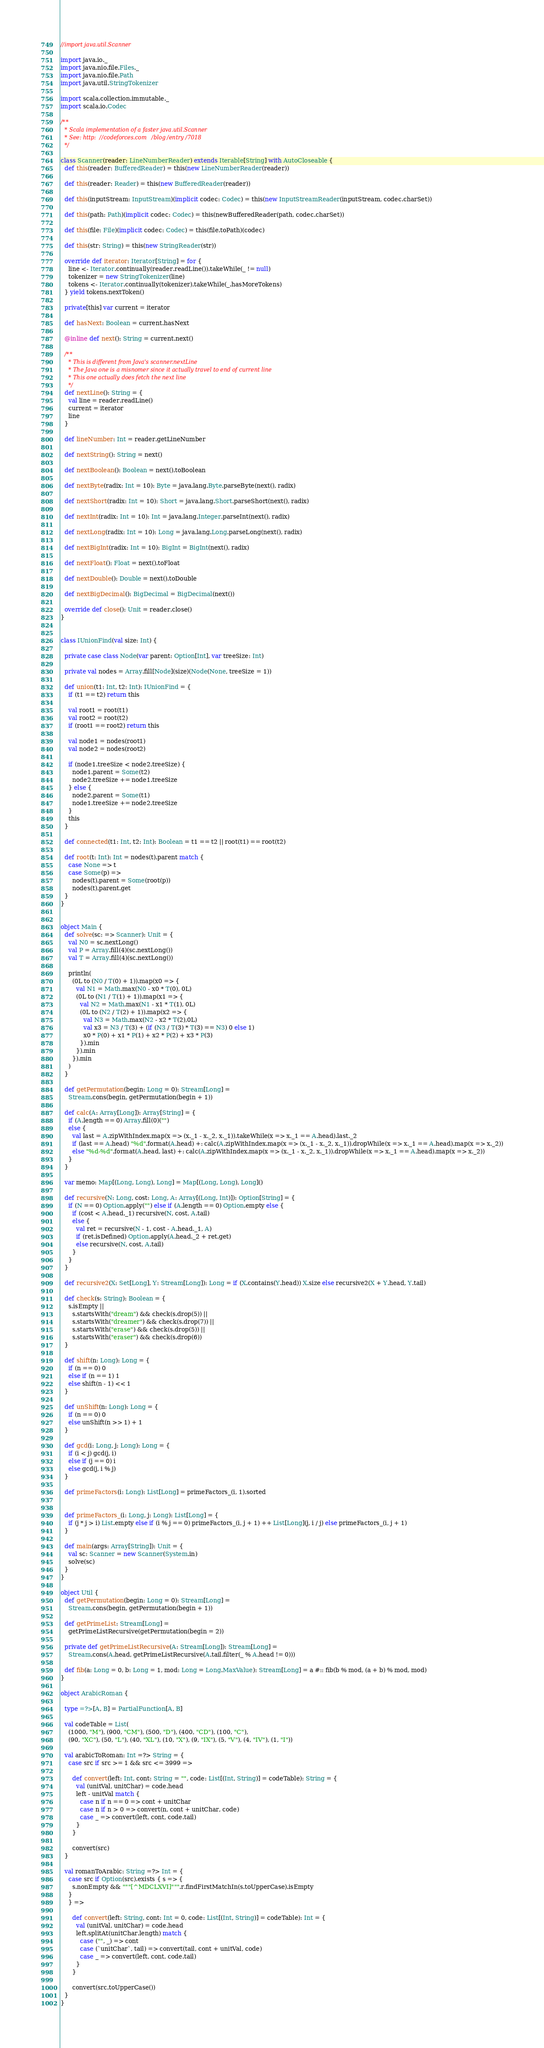<code> <loc_0><loc_0><loc_500><loc_500><_Scala_>//import java.util.Scanner

import java.io._
import java.nio.file.Files._
import java.nio.file.Path
import java.util.StringTokenizer

import scala.collection.immutable._
import scala.io.Codec

/**
  * Scala implementation of a faster java.util.Scanner
  * See: http://codeforces.com/blog/entry/7018
  */

class Scanner(reader: LineNumberReader) extends Iterable[String] with AutoCloseable {
  def this(reader: BufferedReader) = this(new LineNumberReader(reader))

  def this(reader: Reader) = this(new BufferedReader(reader))

  def this(inputStream: InputStream)(implicit codec: Codec) = this(new InputStreamReader(inputStream, codec.charSet))

  def this(path: Path)(implicit codec: Codec) = this(newBufferedReader(path, codec.charSet))

  def this(file: File)(implicit codec: Codec) = this(file.toPath)(codec)

  def this(str: String) = this(new StringReader(str))

  override def iterator: Iterator[String] = for {
    line <- Iterator.continually(reader.readLine()).takeWhile(_ != null)
    tokenizer = new StringTokenizer(line)
    tokens <- Iterator.continually(tokenizer).takeWhile(_.hasMoreTokens)
  } yield tokens.nextToken()

  private[this] var current = iterator

  def hasNext: Boolean = current.hasNext

  @inline def next(): String = current.next()

  /**
    * This is different from Java's scanner.nextLine
    * The Java one is a misnomer since it actually travel to end of current line
    * This one actually does fetch the next line
    */
  def nextLine(): String = {
    val line = reader.readLine()
    current = iterator
    line
  }

  def lineNumber: Int = reader.getLineNumber

  def nextString(): String = next()

  def nextBoolean(): Boolean = next().toBoolean

  def nextByte(radix: Int = 10): Byte = java.lang.Byte.parseByte(next(), radix)

  def nextShort(radix: Int = 10): Short = java.lang.Short.parseShort(next(), radix)

  def nextInt(radix: Int = 10): Int = java.lang.Integer.parseInt(next(), radix)

  def nextLong(radix: Int = 10): Long = java.lang.Long.parseLong(next(), radix)

  def nextBigInt(radix: Int = 10): BigInt = BigInt(next(), radix)

  def nextFloat(): Float = next().toFloat

  def nextDouble(): Double = next().toDouble

  def nextBigDecimal(): BigDecimal = BigDecimal(next())

  override def close(): Unit = reader.close()
}


class IUnionFind(val size: Int) {

  private case class Node(var parent: Option[Int], var treeSize: Int)

  private val nodes = Array.fill[Node](size)(Node(None, treeSize = 1))

  def union(t1: Int, t2: Int): IUnionFind = {
    if (t1 == t2) return this

    val root1 = root(t1)
    val root2 = root(t2)
    if (root1 == root2) return this

    val node1 = nodes(root1)
    val node2 = nodes(root2)

    if (node1.treeSize < node2.treeSize) {
      node1.parent = Some(t2)
      node2.treeSize += node1.treeSize
    } else {
      node2.parent = Some(t1)
      node1.treeSize += node2.treeSize
    }
    this
  }

  def connected(t1: Int, t2: Int): Boolean = t1 == t2 || root(t1) == root(t2)

  def root(t: Int): Int = nodes(t).parent match {
    case None => t
    case Some(p) =>
      nodes(t).parent = Some(root(p))
      nodes(t).parent.get
  }
}


object Main {
  def solve(sc: => Scanner): Unit = {
    val N0 = sc.nextLong()
    val P = Array.fill(4)(sc.nextLong())
    val T = Array.fill(4)(sc.nextLong())

    println(
      (0L to (N0 / T(0) + 1)).map(x0 => {
        val N1 = Math.max(N0 - x0 * T(0), 0L)
        (0L to (N1 / T(1) + 1)).map(x1 => {
          val N2 = Math.max(N1 - x1 * T(1), 0L)
          (0L to (N2 / T(2) + 1)).map(x2 => {
            val N3 = Math.max(N2 - x2 * T(2),0L)
            val x3 = N3 / T(3) + (if (N3 / T(3) * T(3) == N3) 0 else 1)
            x0 * P(0) + x1 * P(1) + x2 * P(2) + x3 * P(3)
          }).min
        }).min
      }).min
    )
  }

  def getPermutation(begin: Long = 0): Stream[Long] =
    Stream.cons(begin, getPermutation(begin + 1))

  def calc(A: Array[Long]): Array[String] = {
    if (A.length == 0) Array.fill(0)("")
    else {
      val last = A.zipWithIndex.map(x => (x._1 - x._2, x._1)).takeWhile(x => x._1 == A.head).last._2
      if (last == A.head) "%d".format(A.head) +: calc(A.zipWithIndex.map(x => (x._1 - x._2, x._1)).dropWhile(x => x._1 == A.head).map(x => x._2))
      else "%d-%d".format(A.head, last) +: calc(A.zipWithIndex.map(x => (x._1 - x._2, x._1)).dropWhile(x => x._1 == A.head).map(x => x._2))
    }
  }

  var memo: Map[(Long, Long), Long] = Map[(Long, Long), Long]()

  def recursive(N: Long, cost: Long, A: Array[(Long, Int)]): Option[String] = {
    if (N == 0) Option.apply("") else if (A.length == 0) Option.empty else {
      if (cost < A.head._1) recursive(N, cost, A.tail)
      else {
        val ret = recursive(N - 1, cost - A.head._1, A)
        if (ret.isDefined) Option.apply(A.head._2 + ret.get)
        else recursive(N, cost, A.tail)
      }
    }
  }

  def recursive2(X: Set[Long], Y: Stream[Long]): Long = if (X.contains(Y.head)) X.size else recursive2(X + Y.head, Y.tail)

  def check(s: String): Boolean = {
    s.isEmpty ||
      s.startsWith("dream") && check(s.drop(5)) ||
      s.startsWith("dreamer") && check(s.drop(7)) ||
      s.startsWith("erase") && check(s.drop(5)) ||
      s.startsWith("eraser") && check(s.drop(6))
  }

  def shift(n: Long): Long = {
    if (n == 0) 0
    else if (n == 1) 1
    else shift(n - 1) << 1
  }

  def unShift(n: Long): Long = {
    if (n == 0) 0
    else unShift(n >> 1) + 1
  }

  def gcd(i: Long, j: Long): Long = {
    if (i < j) gcd(j, i)
    else if (j == 0) i
    else gcd(j, i % j)
  }

  def primeFactors(i: Long): List[Long] = primeFactors_(i, 1).sorted


  def primeFactors_(i: Long, j: Long): List[Long] = {
    if (j * j > i) List.empty else if (i % j == 0) primeFactors_(i, j + 1) ++ List[Long](j, i / j) else primeFactors_(i, j + 1)
  }

  def main(args: Array[String]): Unit = {
    val sc: Scanner = new Scanner(System.in)
    solve(sc)
  }
}

object Util {
  def getPermutation(begin: Long = 0): Stream[Long] =
    Stream.cons(begin, getPermutation(begin + 1))

  def getPrimeList: Stream[Long] =
    getPrimeListRecursive(getPermutation(begin = 2))

  private def getPrimeListRecursive(A: Stream[Long]): Stream[Long] =
    Stream.cons(A.head, getPrimeListRecursive(A.tail.filter(_ % A.head != 0)))

  def fib(a: Long = 0, b: Long = 1, mod: Long = Long.MaxValue): Stream[Long] = a #:: fib(b % mod, (a + b) % mod, mod)
}

object ArabicRoman {

  type =?>[A, B] = PartialFunction[A, B]

  val codeTable = List(
    (1000, "M"), (900, "CM"), (500, "D"), (400, "CD"), (100, "C"),
    (90, "XC"), (50, "L"), (40, "XL"), (10, "X"), (9, "IX"), (5, "V"), (4, "IV"), (1, "I"))

  val arabicToRoman: Int =?> String = {
    case src if src >= 1 && src <= 3999 =>

      def convert(left: Int, cont: String = "", code: List[(Int, String)] = codeTable): String = {
        val (unitVal, unitChar) = code.head
        left - unitVal match {
          case n if n == 0 => cont + unitChar
          case n if n > 0 => convert(n, cont + unitChar, code)
          case _ => convert(left, cont, code.tail)
        }
      }

      convert(src)
  }

  val romanToArabic: String =?> Int = {
    case src if Option(src).exists { s => {
      s.nonEmpty && """[^MDCLXVI]""".r.findFirstMatchIn(s.toUpperCase).isEmpty
    }
    } =>

      def convert(left: String, cont: Int = 0, code: List[(Int, String)] = codeTable): Int = {
        val (unitVal, unitChar) = code.head
        left.splitAt(unitChar.length) match {
          case ("", _) => cont
          case (`unitChar`, tail) => convert(tail, cont + unitVal, code)
          case _ => convert(left, cont, code.tail)
        }
      }

      convert(src.toUpperCase())
  }
}

</code> 